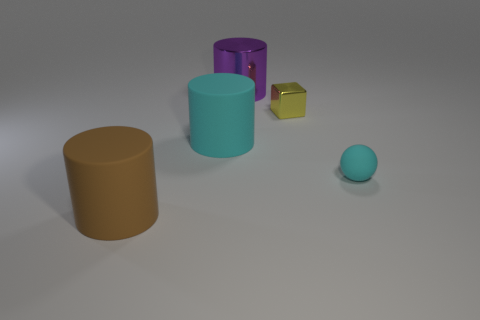Subtract all brown cylinders. How many cylinders are left? 2 Add 4 big brown matte blocks. How many objects exist? 9 Subtract all purple cylinders. How many cylinders are left? 2 Subtract all spheres. How many objects are left? 4 Subtract all brown blocks. Subtract all gray cylinders. How many blocks are left? 1 Subtract all yellow metal objects. Subtract all tiny cyan matte spheres. How many objects are left? 3 Add 1 matte objects. How many matte objects are left? 4 Add 3 rubber balls. How many rubber balls exist? 4 Subtract 1 purple cylinders. How many objects are left? 4 